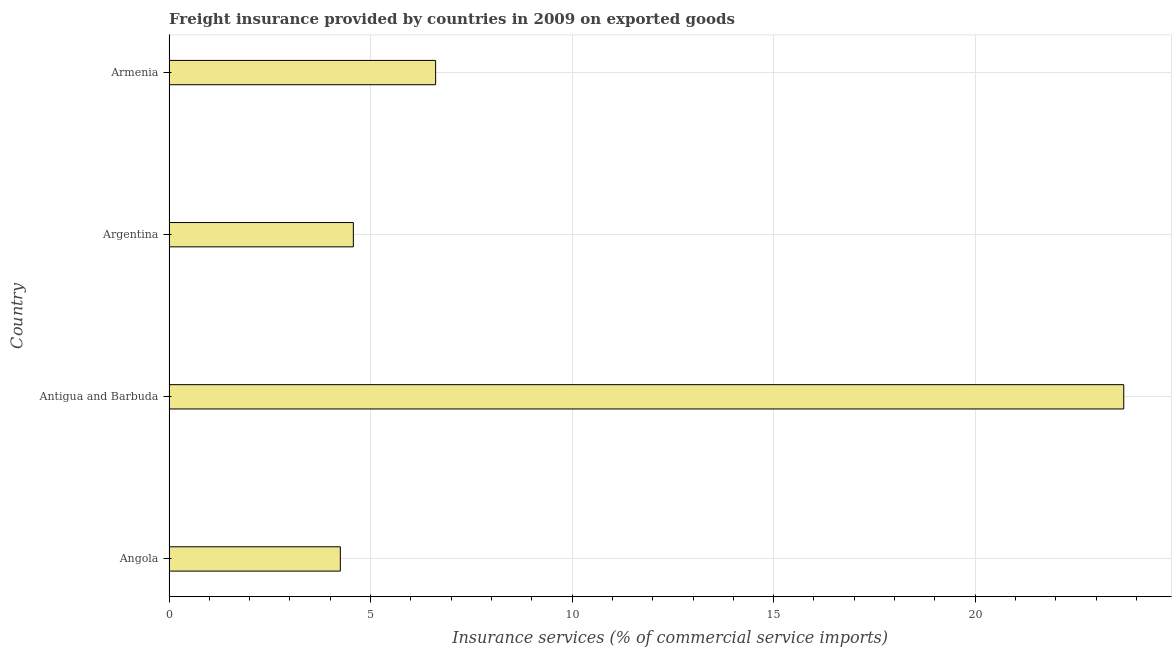Does the graph contain grids?
Provide a succinct answer. Yes. What is the title of the graph?
Keep it short and to the point. Freight insurance provided by countries in 2009 on exported goods . What is the label or title of the X-axis?
Offer a terse response. Insurance services (% of commercial service imports). What is the label or title of the Y-axis?
Offer a very short reply. Country. What is the freight insurance in Angola?
Provide a short and direct response. 4.25. Across all countries, what is the maximum freight insurance?
Provide a succinct answer. 23.69. Across all countries, what is the minimum freight insurance?
Keep it short and to the point. 4.25. In which country was the freight insurance maximum?
Keep it short and to the point. Antigua and Barbuda. In which country was the freight insurance minimum?
Offer a very short reply. Angola. What is the sum of the freight insurance?
Make the answer very short. 39.13. What is the difference between the freight insurance in Angola and Antigua and Barbuda?
Your answer should be compact. -19.44. What is the average freight insurance per country?
Make the answer very short. 9.78. What is the median freight insurance?
Ensure brevity in your answer.  5.59. In how many countries, is the freight insurance greater than 16 %?
Your answer should be very brief. 1. What is the ratio of the freight insurance in Angola to that in Argentina?
Your answer should be very brief. 0.93. Is the freight insurance in Antigua and Barbuda less than that in Argentina?
Provide a short and direct response. No. Is the difference between the freight insurance in Argentina and Armenia greater than the difference between any two countries?
Your answer should be compact. No. What is the difference between the highest and the second highest freight insurance?
Make the answer very short. 17.07. Is the sum of the freight insurance in Angola and Armenia greater than the maximum freight insurance across all countries?
Keep it short and to the point. No. What is the difference between the highest and the lowest freight insurance?
Give a very brief answer. 19.44. Are all the bars in the graph horizontal?
Give a very brief answer. Yes. What is the difference between two consecutive major ticks on the X-axis?
Provide a short and direct response. 5. Are the values on the major ticks of X-axis written in scientific E-notation?
Your response must be concise. No. What is the Insurance services (% of commercial service imports) of Angola?
Keep it short and to the point. 4.25. What is the Insurance services (% of commercial service imports) in Antigua and Barbuda?
Provide a succinct answer. 23.69. What is the Insurance services (% of commercial service imports) in Argentina?
Your response must be concise. 4.57. What is the Insurance services (% of commercial service imports) in Armenia?
Keep it short and to the point. 6.62. What is the difference between the Insurance services (% of commercial service imports) in Angola and Antigua and Barbuda?
Give a very brief answer. -19.44. What is the difference between the Insurance services (% of commercial service imports) in Angola and Argentina?
Your answer should be very brief. -0.32. What is the difference between the Insurance services (% of commercial service imports) in Angola and Armenia?
Your answer should be compact. -2.36. What is the difference between the Insurance services (% of commercial service imports) in Antigua and Barbuda and Argentina?
Ensure brevity in your answer.  19.11. What is the difference between the Insurance services (% of commercial service imports) in Antigua and Barbuda and Armenia?
Ensure brevity in your answer.  17.07. What is the difference between the Insurance services (% of commercial service imports) in Argentina and Armenia?
Provide a succinct answer. -2.04. What is the ratio of the Insurance services (% of commercial service imports) in Angola to that in Antigua and Barbuda?
Keep it short and to the point. 0.18. What is the ratio of the Insurance services (% of commercial service imports) in Angola to that in Argentina?
Your answer should be compact. 0.93. What is the ratio of the Insurance services (% of commercial service imports) in Angola to that in Armenia?
Provide a short and direct response. 0.64. What is the ratio of the Insurance services (% of commercial service imports) in Antigua and Barbuda to that in Argentina?
Your answer should be compact. 5.18. What is the ratio of the Insurance services (% of commercial service imports) in Antigua and Barbuda to that in Armenia?
Keep it short and to the point. 3.58. What is the ratio of the Insurance services (% of commercial service imports) in Argentina to that in Armenia?
Provide a succinct answer. 0.69. 